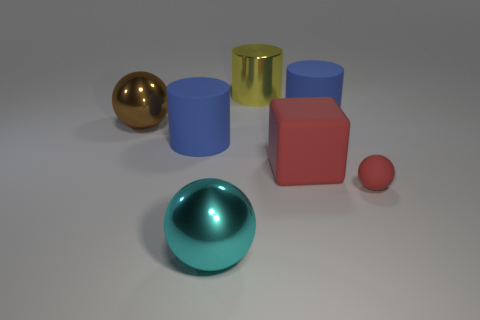Is the number of tiny gray balls the same as the number of tiny things?
Give a very brief answer. No. What is the material of the red ball?
Make the answer very short. Rubber. There is a big yellow metal object; what shape is it?
Provide a succinct answer. Cylinder. What number of other large matte cubes are the same color as the large cube?
Your answer should be very brief. 0. There is a blue object that is behind the large matte cylinder to the left of the large metallic ball in front of the large brown ball; what is its material?
Ensure brevity in your answer.  Rubber. What number of green things are either small shiny cylinders or matte cubes?
Give a very brief answer. 0. What is the size of the ball that is right of the red thing that is on the left side of the blue cylinder that is right of the big yellow metallic cylinder?
Your answer should be very brief. Small. There is another matte thing that is the same shape as the brown thing; what size is it?
Give a very brief answer. Small. What number of large objects are brown things or matte objects?
Provide a short and direct response. 4. Is the material of the large sphere that is in front of the large brown object the same as the large cylinder right of the matte cube?
Provide a short and direct response. No. 